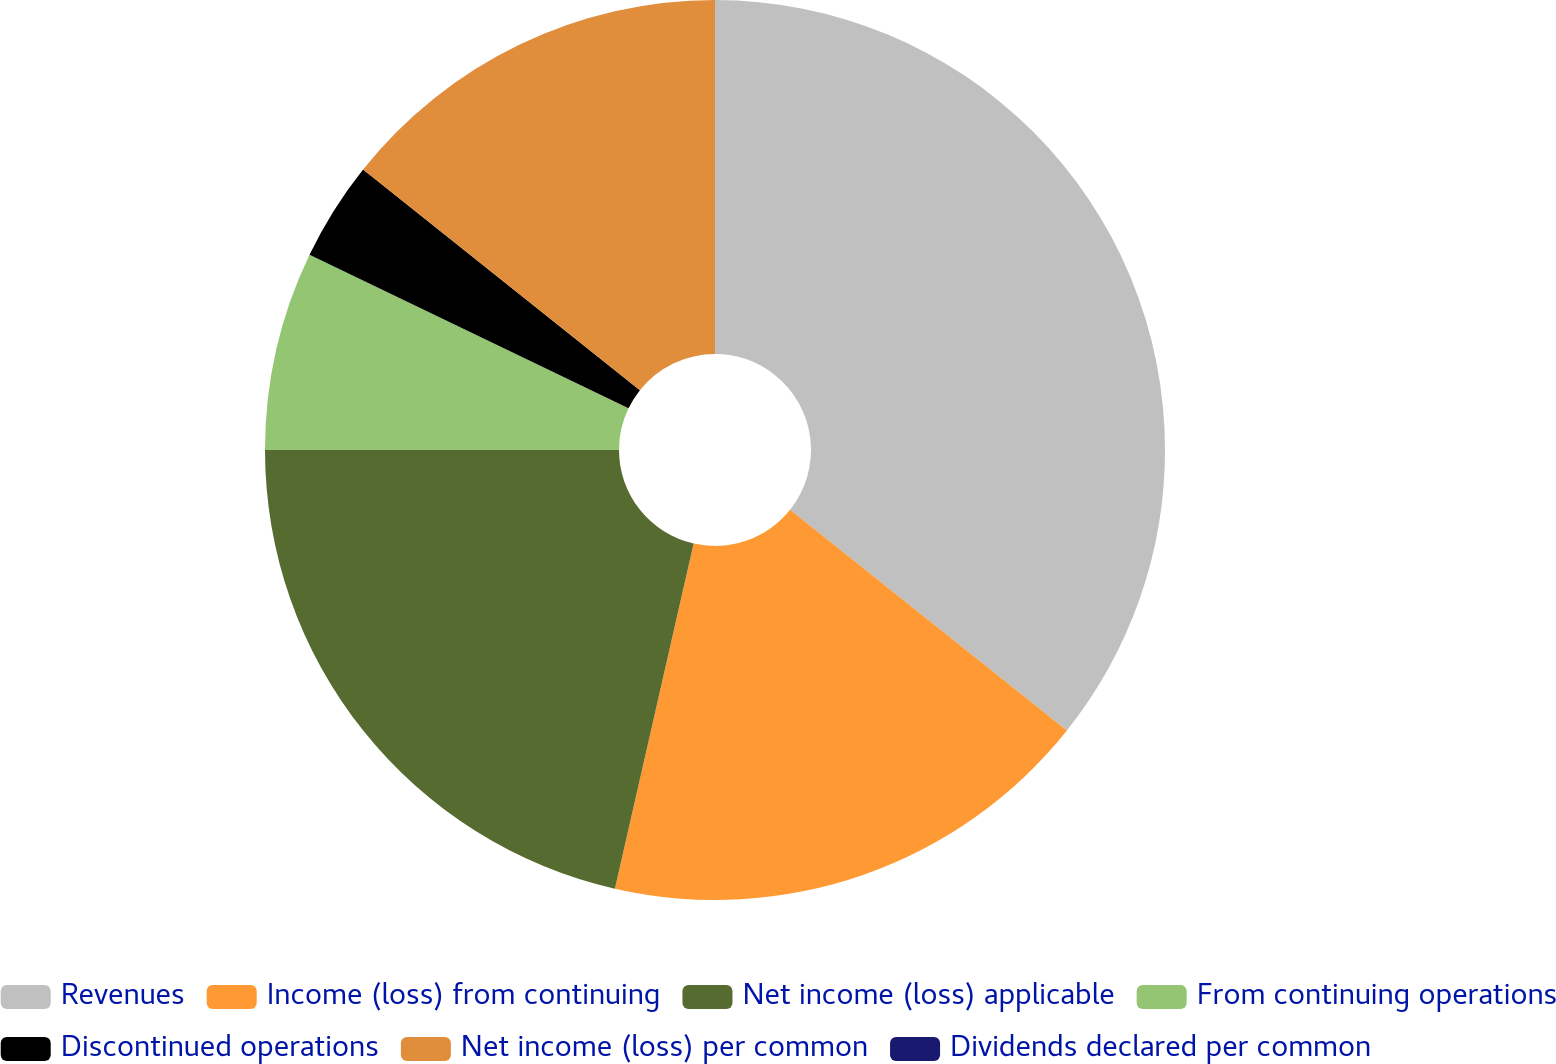<chart> <loc_0><loc_0><loc_500><loc_500><pie_chart><fcel>Revenues<fcel>Income (loss) from continuing<fcel>Net income (loss) applicable<fcel>From continuing operations<fcel>Discontinued operations<fcel>Net income (loss) per common<fcel>Dividends declared per common<nl><fcel>35.71%<fcel>17.86%<fcel>21.43%<fcel>7.14%<fcel>3.57%<fcel>14.29%<fcel>0.0%<nl></chart> 